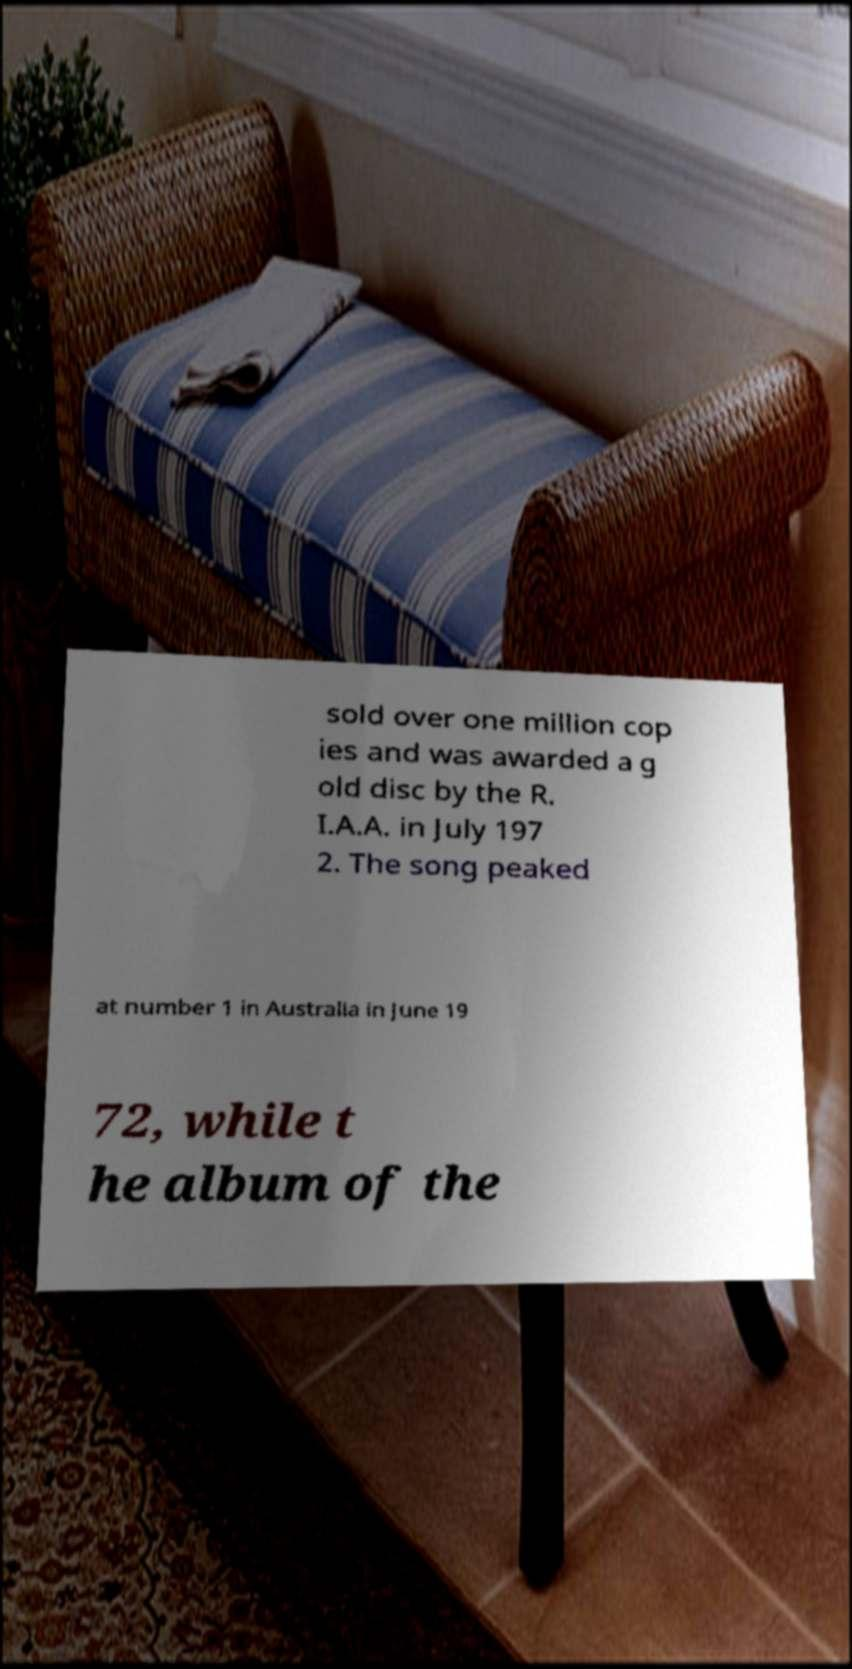Can you read and provide the text displayed in the image?This photo seems to have some interesting text. Can you extract and type it out for me? sold over one million cop ies and was awarded a g old disc by the R. I.A.A. in July 197 2. The song peaked at number 1 in Australia in June 19 72, while t he album of the 